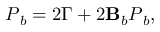Convert formula to latex. <formula><loc_0><loc_0><loc_500><loc_500>P _ { b } = 2 \Gamma + 2 B _ { b } P _ { b } ,</formula> 